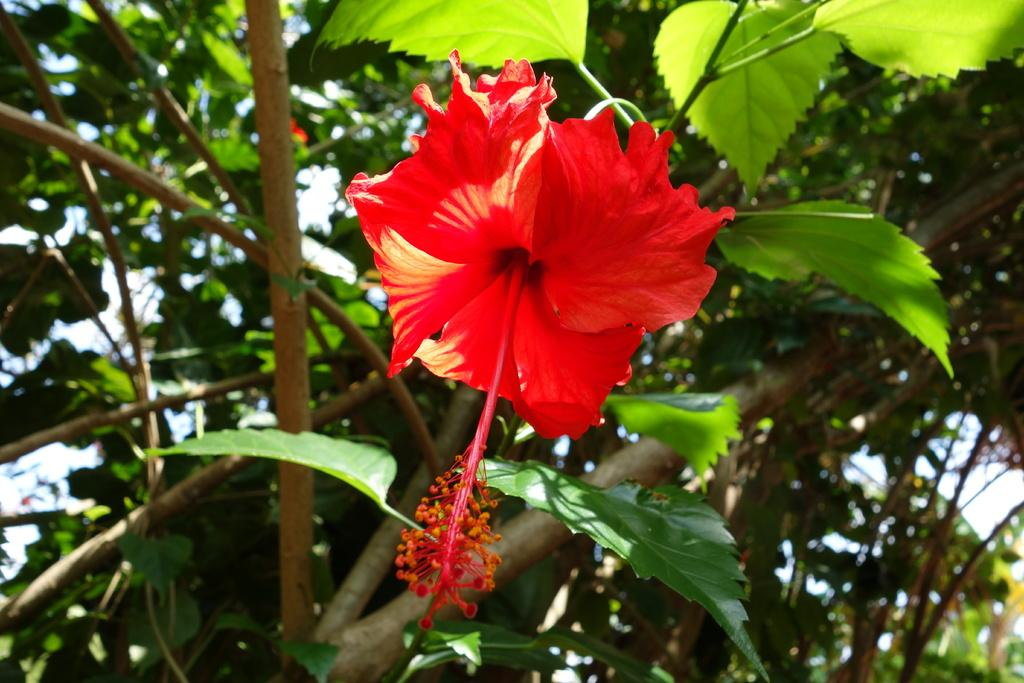What type of vegetation can be seen in the image? There are trees in the image. Are there any other plants visible besides the trees? Yes, there is a flower in the image. What can be seen in the background of the image? The sky is visible in the image. What songs can be heard playing in the background of the image? There is no audio or music present in the image, so it is not possible to determine what songs might be heard. 